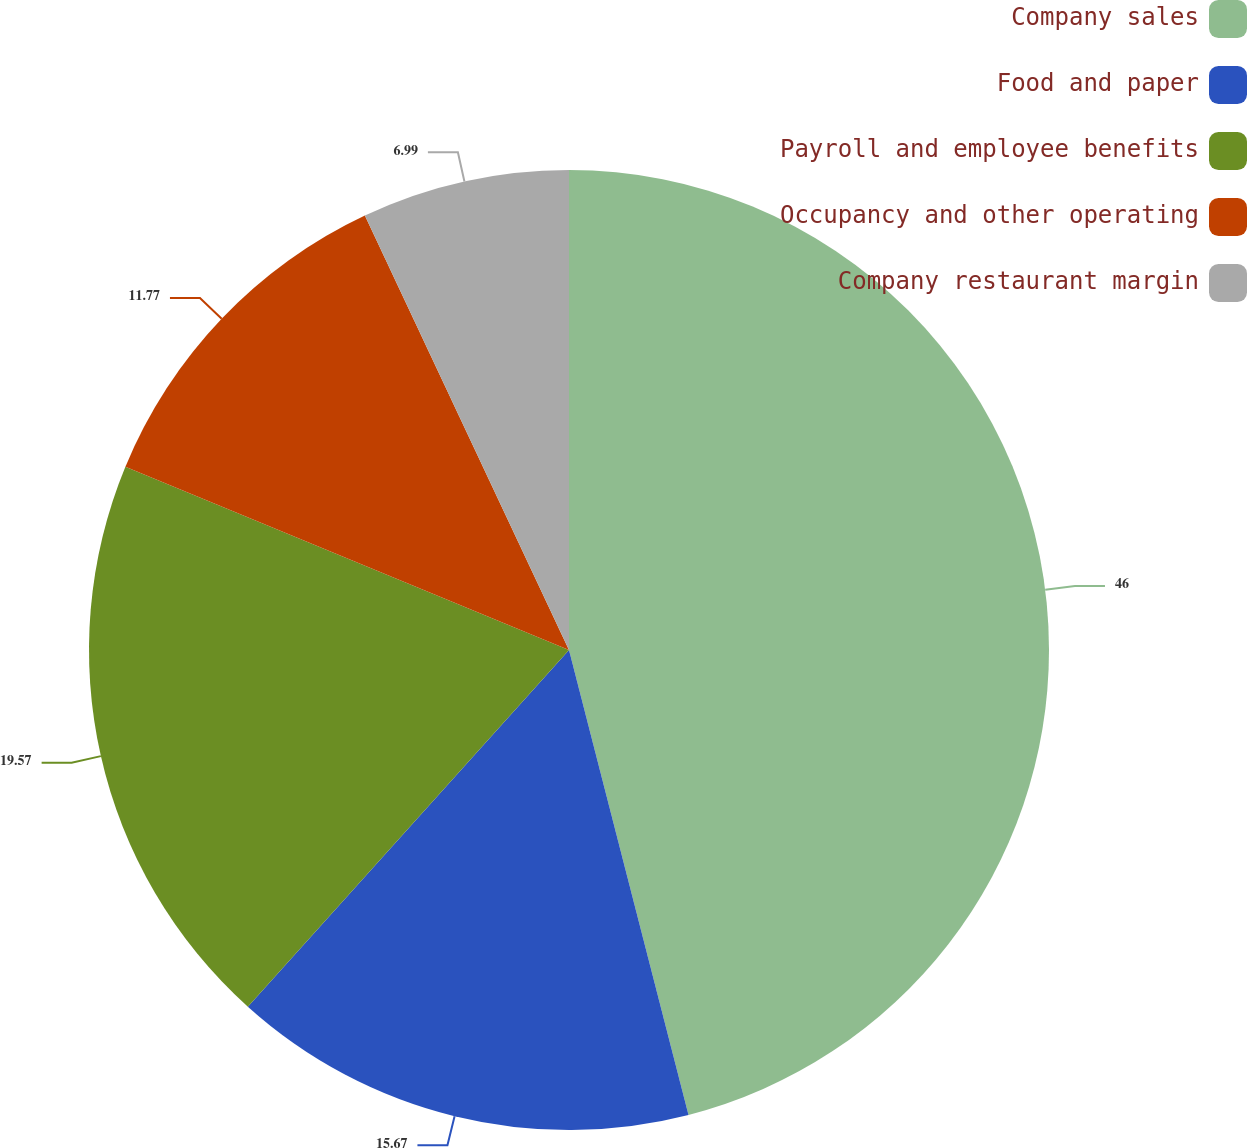<chart> <loc_0><loc_0><loc_500><loc_500><pie_chart><fcel>Company sales<fcel>Food and paper<fcel>Payroll and employee benefits<fcel>Occupancy and other operating<fcel>Company restaurant margin<nl><fcel>45.99%<fcel>15.67%<fcel>19.57%<fcel>11.77%<fcel>6.99%<nl></chart> 